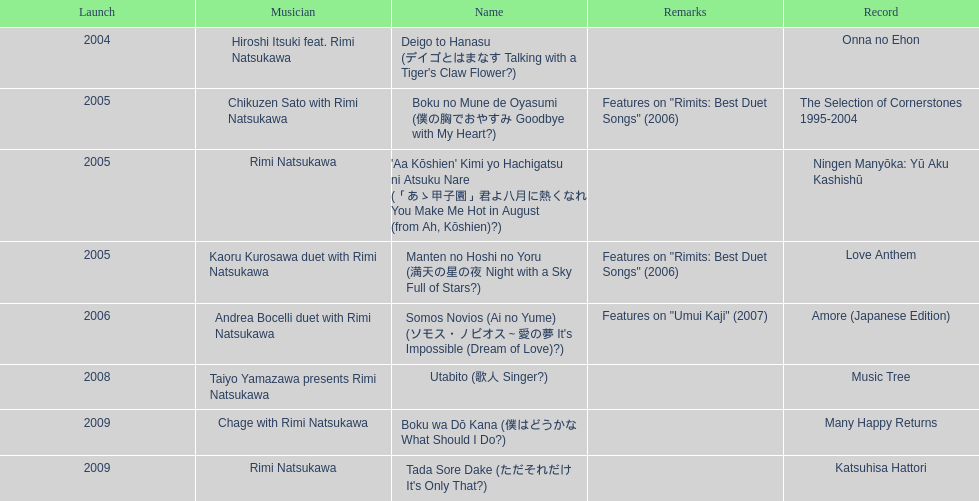When was onna no ehon released? 2004. When was the selection of cornerstones 1995-2004 released? 2005. What was released in 2008? Music Tree. 